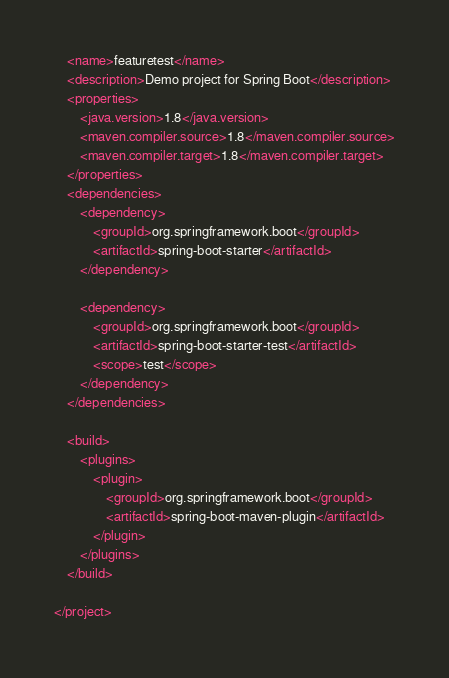<code> <loc_0><loc_0><loc_500><loc_500><_XML_>    <name>featuretest</name>
    <description>Demo project for Spring Boot</description>
    <properties>
        <java.version>1.8</java.version>
        <maven.compiler.source>1.8</maven.compiler.source>
        <maven.compiler.target>1.8</maven.compiler.target>
    </properties>
    <dependencies>
        <dependency>
            <groupId>org.springframework.boot</groupId>
            <artifactId>spring-boot-starter</artifactId>
        </dependency>

        <dependency>
            <groupId>org.springframework.boot</groupId>
            <artifactId>spring-boot-starter-test</artifactId>
            <scope>test</scope>
        </dependency>
    </dependencies>

    <build>
        <plugins>
            <plugin>
                <groupId>org.springframework.boot</groupId>
                <artifactId>spring-boot-maven-plugin</artifactId>
            </plugin>
        </plugins>
    </build>

</project>
</code> 